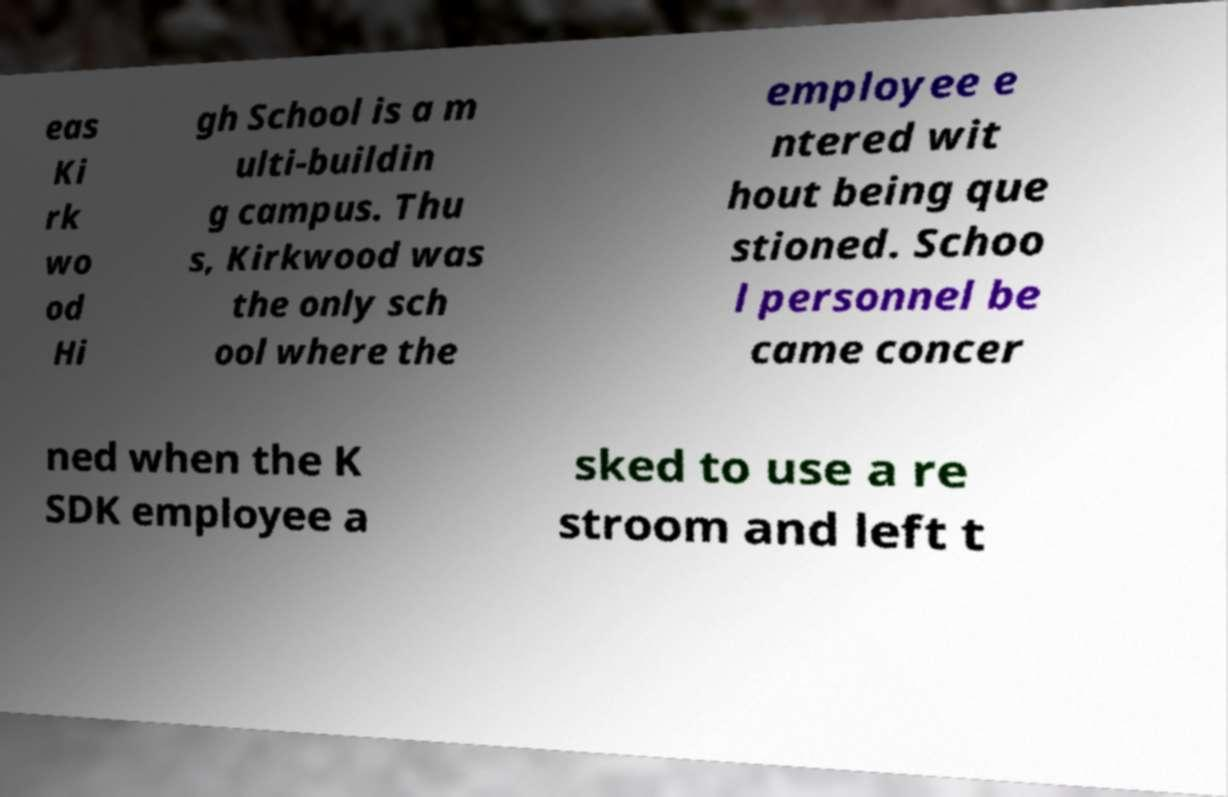Could you assist in decoding the text presented in this image and type it out clearly? eas Ki rk wo od Hi gh School is a m ulti-buildin g campus. Thu s, Kirkwood was the only sch ool where the employee e ntered wit hout being que stioned. Schoo l personnel be came concer ned when the K SDK employee a sked to use a re stroom and left t 